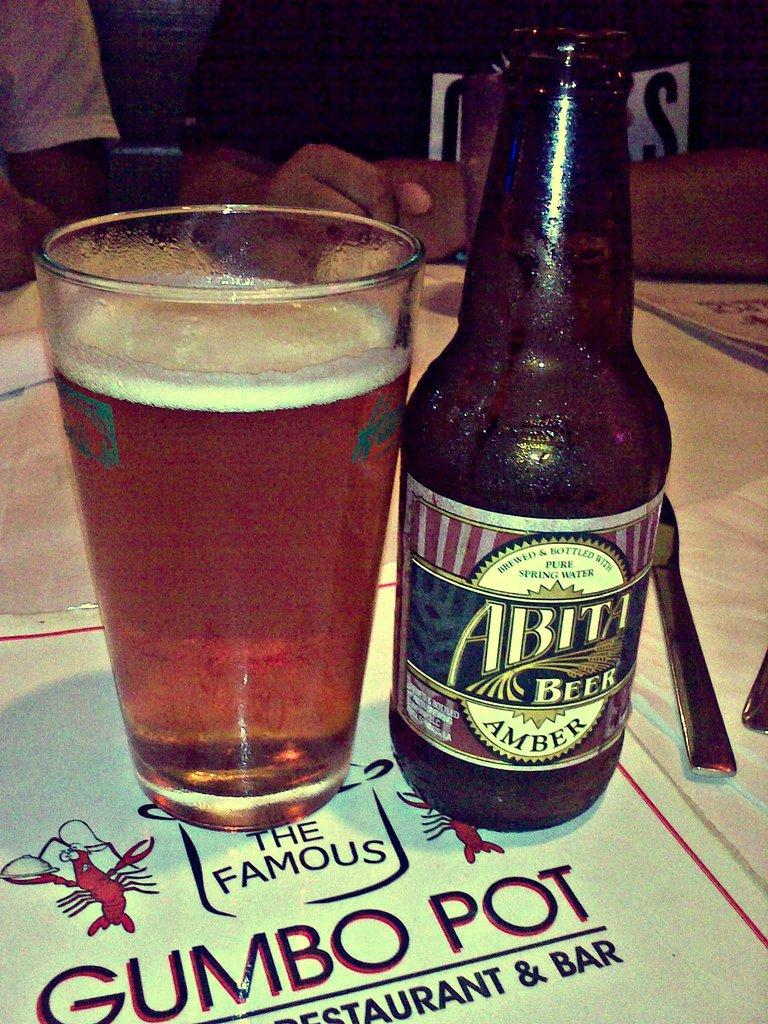Provide a one-sentence caption for the provided image. A glass and bottle of Abita Beer on top of a menu for the Famous Gumbo Pot Restaurant. 